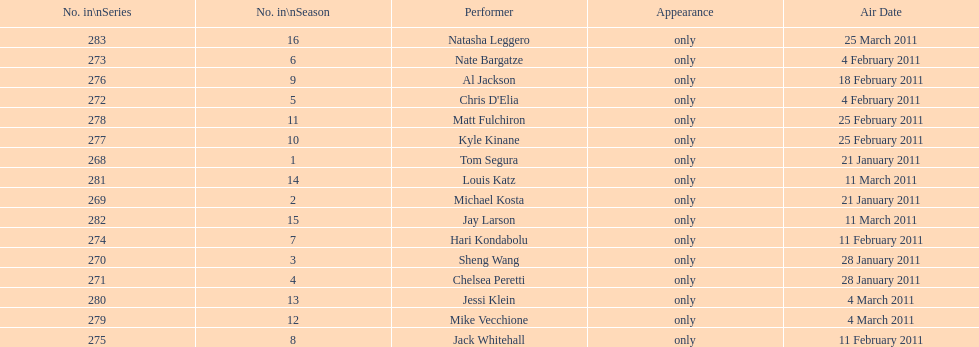Can you give me this table as a dict? {'header': ['No. in\\nSeries', 'No. in\\nSeason', 'Performer', 'Appearance', 'Air Date'], 'rows': [['283', '16', 'Natasha Leggero', 'only', '25 March 2011'], ['273', '6', 'Nate Bargatze', 'only', '4 February 2011'], ['276', '9', 'Al Jackson', 'only', '18 February 2011'], ['272', '5', "Chris D'Elia", 'only', '4 February 2011'], ['278', '11', 'Matt Fulchiron', 'only', '25 February 2011'], ['277', '10', 'Kyle Kinane', 'only', '25 February 2011'], ['268', '1', 'Tom Segura', 'only', '21 January 2011'], ['281', '14', 'Louis Katz', 'only', '11 March 2011'], ['269', '2', 'Michael Kosta', 'only', '21 January 2011'], ['282', '15', 'Jay Larson', 'only', '11 March 2011'], ['274', '7', 'Hari Kondabolu', 'only', '11 February 2011'], ['270', '3', 'Sheng Wang', 'only', '28 January 2011'], ['271', '4', 'Chelsea Peretti', 'only', '28 January 2011'], ['280', '13', 'Jessi Klein', 'only', '4 March 2011'], ['279', '12', 'Mike Vecchione', 'only', '4 March 2011'], ['275', '8', 'Jack Whitehall', 'only', '11 February 2011']]} Did al jackson air before or after kyle kinane? Before. 